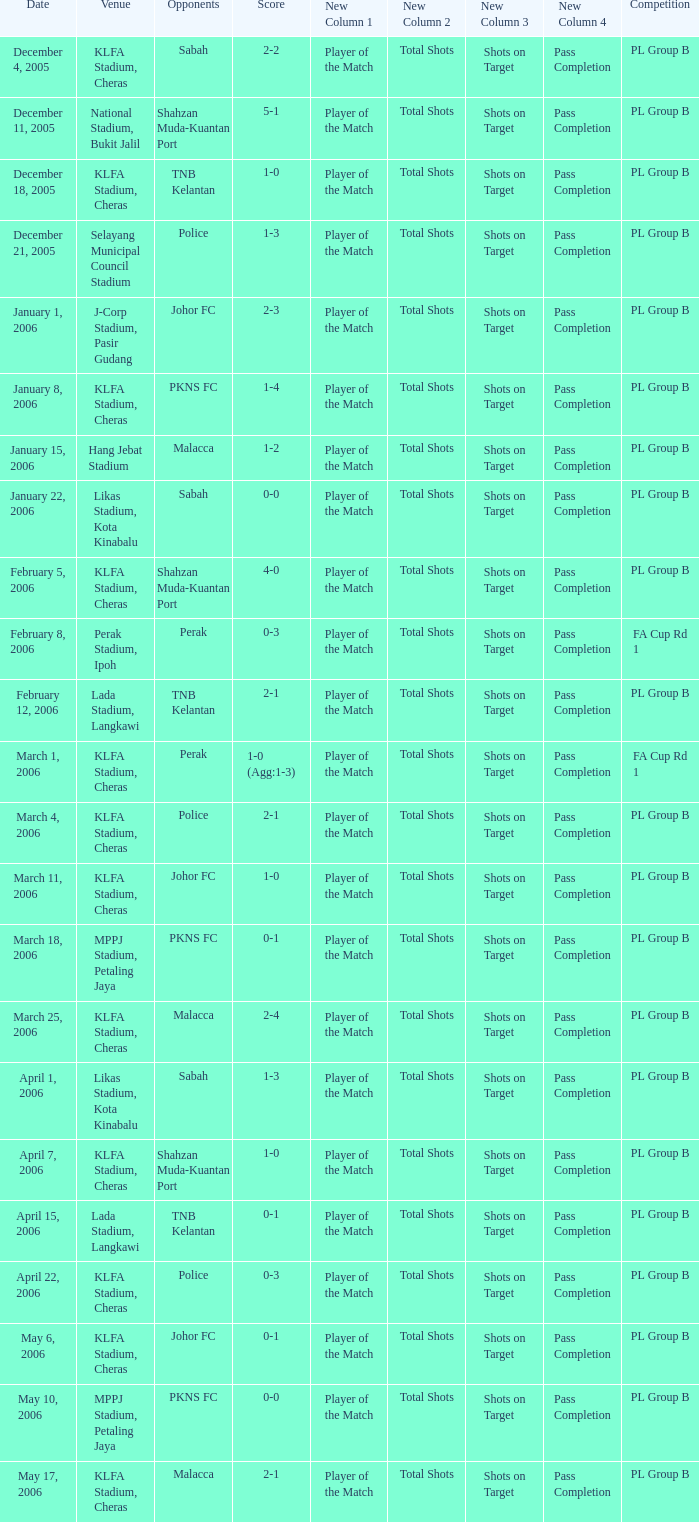Which Competition has Opponents of pkns fc, and a Score of 0-0? PL Group B. 